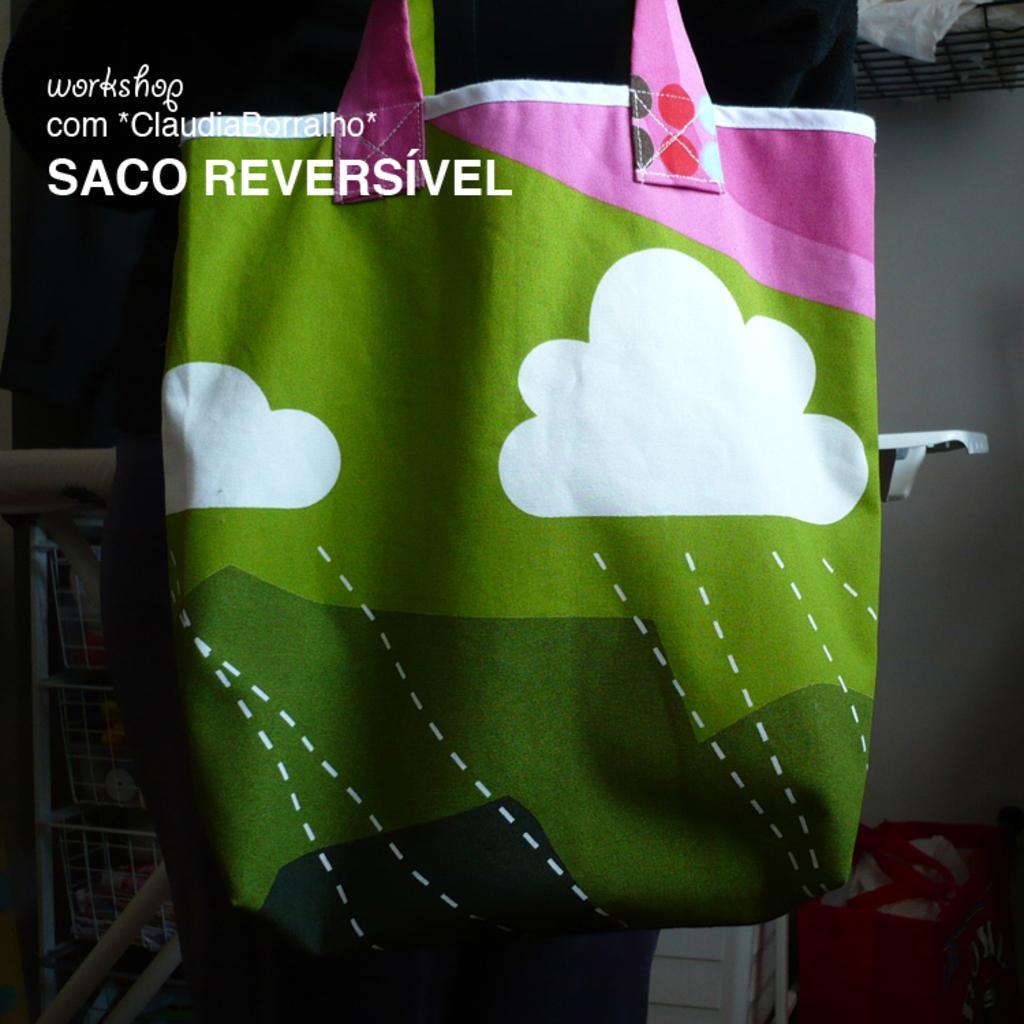Please provide a concise description of this image. A bag on which there are clouds designed on it and this bag is of three colors white,red and pink. 